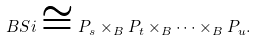Convert formula to latex. <formula><loc_0><loc_0><loc_500><loc_500>\ B S i \cong P _ { s } \times _ { B } P _ { t } \times _ { B } \cdots \times _ { B } P _ { u } .</formula> 